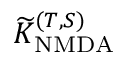<formula> <loc_0><loc_0><loc_500><loc_500>\widetilde { K } _ { N M D A } ^ { ( T , S ) }</formula> 